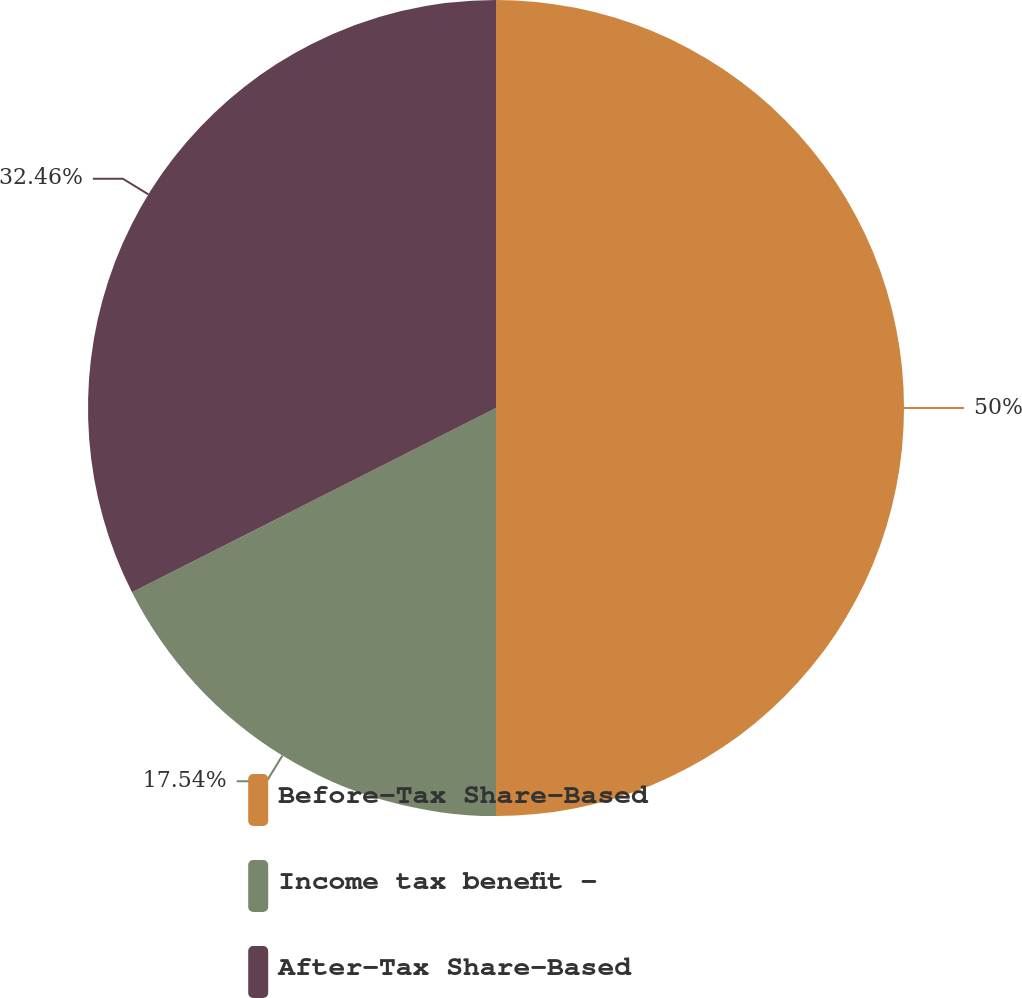Convert chart. <chart><loc_0><loc_0><loc_500><loc_500><pie_chart><fcel>Before-Tax Share-Based<fcel>Income tax benefit -<fcel>After-Tax Share-Based<nl><fcel>50.0%<fcel>17.54%<fcel>32.46%<nl></chart> 